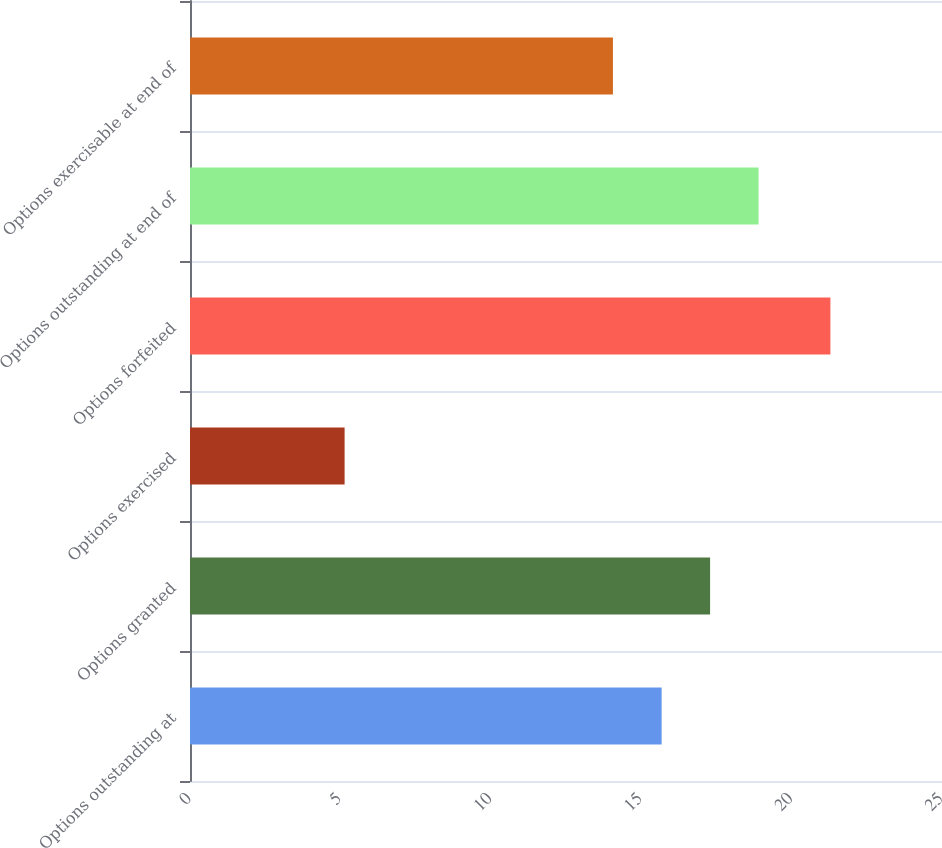Convert chart. <chart><loc_0><loc_0><loc_500><loc_500><bar_chart><fcel>Options outstanding at<fcel>Options granted<fcel>Options exercised<fcel>Options forfeited<fcel>Options outstanding at end of<fcel>Options exercisable at end of<nl><fcel>15.68<fcel>17.29<fcel>5.14<fcel>21.29<fcel>18.9<fcel>14.06<nl></chart> 